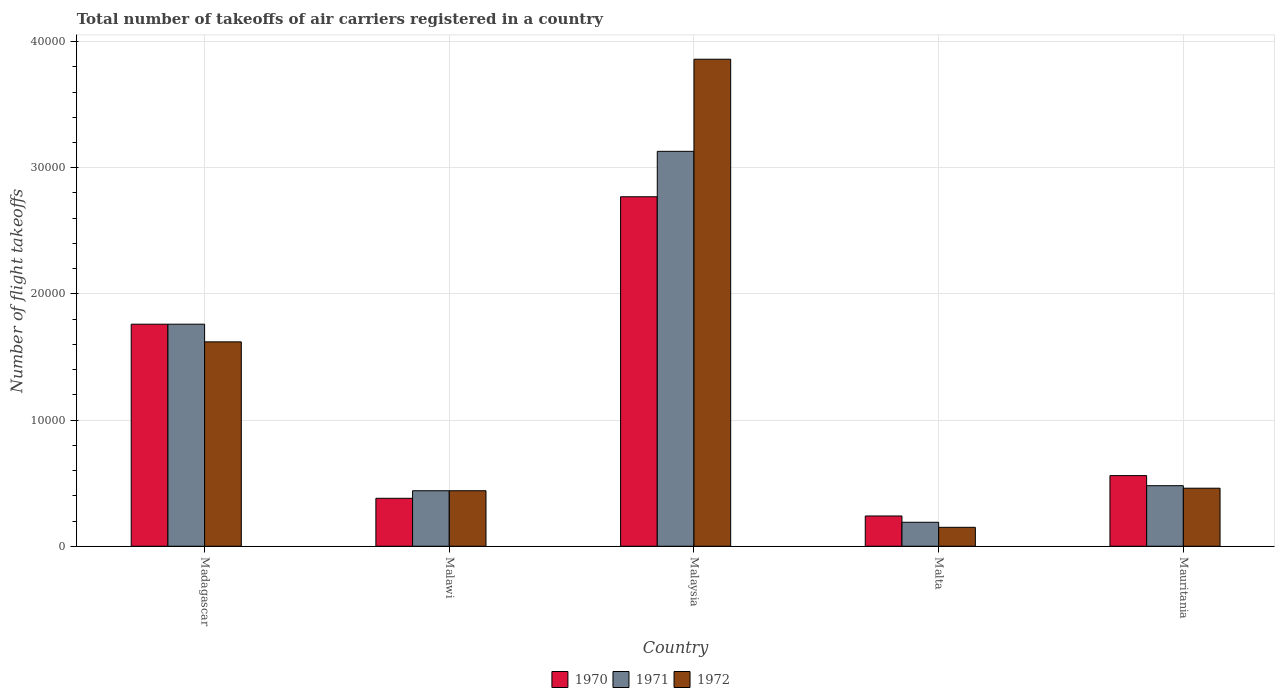Are the number of bars on each tick of the X-axis equal?
Keep it short and to the point. Yes. How many bars are there on the 1st tick from the left?
Make the answer very short. 3. What is the label of the 3rd group of bars from the left?
Offer a terse response. Malaysia. In how many cases, is the number of bars for a given country not equal to the number of legend labels?
Provide a short and direct response. 0. What is the total number of flight takeoffs in 1972 in Mauritania?
Make the answer very short. 4600. Across all countries, what is the maximum total number of flight takeoffs in 1972?
Give a very brief answer. 3.86e+04. Across all countries, what is the minimum total number of flight takeoffs in 1972?
Your answer should be very brief. 1500. In which country was the total number of flight takeoffs in 1972 maximum?
Your response must be concise. Malaysia. In which country was the total number of flight takeoffs in 1972 minimum?
Ensure brevity in your answer.  Malta. What is the total total number of flight takeoffs in 1972 in the graph?
Offer a terse response. 6.53e+04. What is the difference between the total number of flight takeoffs in 1972 in Madagascar and that in Malta?
Your answer should be compact. 1.47e+04. What is the difference between the total number of flight takeoffs in 1971 in Mauritania and the total number of flight takeoffs in 1972 in Madagascar?
Your response must be concise. -1.14e+04. What is the average total number of flight takeoffs in 1972 per country?
Provide a succinct answer. 1.31e+04. What is the difference between the total number of flight takeoffs of/in 1970 and total number of flight takeoffs of/in 1971 in Malawi?
Make the answer very short. -600. What is the ratio of the total number of flight takeoffs in 1970 in Madagascar to that in Mauritania?
Give a very brief answer. 3.14. What is the difference between the highest and the second highest total number of flight takeoffs in 1970?
Ensure brevity in your answer.  -1.01e+04. What is the difference between the highest and the lowest total number of flight takeoffs in 1970?
Your answer should be compact. 2.53e+04. How many countries are there in the graph?
Ensure brevity in your answer.  5. What is the difference between two consecutive major ticks on the Y-axis?
Your answer should be very brief. 10000. Are the values on the major ticks of Y-axis written in scientific E-notation?
Ensure brevity in your answer.  No. Does the graph contain grids?
Make the answer very short. Yes. Where does the legend appear in the graph?
Offer a very short reply. Bottom center. How many legend labels are there?
Provide a succinct answer. 3. What is the title of the graph?
Offer a very short reply. Total number of takeoffs of air carriers registered in a country. What is the label or title of the Y-axis?
Your answer should be very brief. Number of flight takeoffs. What is the Number of flight takeoffs of 1970 in Madagascar?
Your answer should be compact. 1.76e+04. What is the Number of flight takeoffs of 1971 in Madagascar?
Your answer should be very brief. 1.76e+04. What is the Number of flight takeoffs in 1972 in Madagascar?
Keep it short and to the point. 1.62e+04. What is the Number of flight takeoffs in 1970 in Malawi?
Offer a terse response. 3800. What is the Number of flight takeoffs in 1971 in Malawi?
Offer a very short reply. 4400. What is the Number of flight takeoffs of 1972 in Malawi?
Provide a succinct answer. 4400. What is the Number of flight takeoffs of 1970 in Malaysia?
Your response must be concise. 2.77e+04. What is the Number of flight takeoffs in 1971 in Malaysia?
Your answer should be very brief. 3.13e+04. What is the Number of flight takeoffs of 1972 in Malaysia?
Provide a succinct answer. 3.86e+04. What is the Number of flight takeoffs in 1970 in Malta?
Ensure brevity in your answer.  2400. What is the Number of flight takeoffs of 1971 in Malta?
Provide a short and direct response. 1900. What is the Number of flight takeoffs of 1972 in Malta?
Provide a short and direct response. 1500. What is the Number of flight takeoffs in 1970 in Mauritania?
Provide a succinct answer. 5600. What is the Number of flight takeoffs of 1971 in Mauritania?
Offer a very short reply. 4800. What is the Number of flight takeoffs in 1972 in Mauritania?
Your answer should be compact. 4600. Across all countries, what is the maximum Number of flight takeoffs of 1970?
Offer a terse response. 2.77e+04. Across all countries, what is the maximum Number of flight takeoffs of 1971?
Offer a very short reply. 3.13e+04. Across all countries, what is the maximum Number of flight takeoffs of 1972?
Ensure brevity in your answer.  3.86e+04. Across all countries, what is the minimum Number of flight takeoffs in 1970?
Offer a very short reply. 2400. Across all countries, what is the minimum Number of flight takeoffs in 1971?
Make the answer very short. 1900. Across all countries, what is the minimum Number of flight takeoffs in 1972?
Keep it short and to the point. 1500. What is the total Number of flight takeoffs in 1970 in the graph?
Make the answer very short. 5.71e+04. What is the total Number of flight takeoffs in 1971 in the graph?
Keep it short and to the point. 6.00e+04. What is the total Number of flight takeoffs in 1972 in the graph?
Make the answer very short. 6.53e+04. What is the difference between the Number of flight takeoffs of 1970 in Madagascar and that in Malawi?
Your response must be concise. 1.38e+04. What is the difference between the Number of flight takeoffs of 1971 in Madagascar and that in Malawi?
Make the answer very short. 1.32e+04. What is the difference between the Number of flight takeoffs in 1972 in Madagascar and that in Malawi?
Offer a very short reply. 1.18e+04. What is the difference between the Number of flight takeoffs in 1970 in Madagascar and that in Malaysia?
Your answer should be compact. -1.01e+04. What is the difference between the Number of flight takeoffs of 1971 in Madagascar and that in Malaysia?
Your answer should be very brief. -1.37e+04. What is the difference between the Number of flight takeoffs of 1972 in Madagascar and that in Malaysia?
Offer a terse response. -2.24e+04. What is the difference between the Number of flight takeoffs of 1970 in Madagascar and that in Malta?
Make the answer very short. 1.52e+04. What is the difference between the Number of flight takeoffs of 1971 in Madagascar and that in Malta?
Your response must be concise. 1.57e+04. What is the difference between the Number of flight takeoffs in 1972 in Madagascar and that in Malta?
Offer a very short reply. 1.47e+04. What is the difference between the Number of flight takeoffs in 1970 in Madagascar and that in Mauritania?
Give a very brief answer. 1.20e+04. What is the difference between the Number of flight takeoffs of 1971 in Madagascar and that in Mauritania?
Your response must be concise. 1.28e+04. What is the difference between the Number of flight takeoffs of 1972 in Madagascar and that in Mauritania?
Your answer should be compact. 1.16e+04. What is the difference between the Number of flight takeoffs of 1970 in Malawi and that in Malaysia?
Make the answer very short. -2.39e+04. What is the difference between the Number of flight takeoffs of 1971 in Malawi and that in Malaysia?
Offer a very short reply. -2.69e+04. What is the difference between the Number of flight takeoffs of 1972 in Malawi and that in Malaysia?
Your answer should be compact. -3.42e+04. What is the difference between the Number of flight takeoffs in 1970 in Malawi and that in Malta?
Keep it short and to the point. 1400. What is the difference between the Number of flight takeoffs in 1971 in Malawi and that in Malta?
Offer a very short reply. 2500. What is the difference between the Number of flight takeoffs of 1972 in Malawi and that in Malta?
Give a very brief answer. 2900. What is the difference between the Number of flight takeoffs in 1970 in Malawi and that in Mauritania?
Your answer should be very brief. -1800. What is the difference between the Number of flight takeoffs of 1971 in Malawi and that in Mauritania?
Provide a succinct answer. -400. What is the difference between the Number of flight takeoffs in 1972 in Malawi and that in Mauritania?
Provide a succinct answer. -200. What is the difference between the Number of flight takeoffs in 1970 in Malaysia and that in Malta?
Provide a short and direct response. 2.53e+04. What is the difference between the Number of flight takeoffs in 1971 in Malaysia and that in Malta?
Your answer should be very brief. 2.94e+04. What is the difference between the Number of flight takeoffs in 1972 in Malaysia and that in Malta?
Offer a terse response. 3.71e+04. What is the difference between the Number of flight takeoffs of 1970 in Malaysia and that in Mauritania?
Keep it short and to the point. 2.21e+04. What is the difference between the Number of flight takeoffs in 1971 in Malaysia and that in Mauritania?
Offer a very short reply. 2.65e+04. What is the difference between the Number of flight takeoffs in 1972 in Malaysia and that in Mauritania?
Your answer should be very brief. 3.40e+04. What is the difference between the Number of flight takeoffs of 1970 in Malta and that in Mauritania?
Keep it short and to the point. -3200. What is the difference between the Number of flight takeoffs of 1971 in Malta and that in Mauritania?
Offer a terse response. -2900. What is the difference between the Number of flight takeoffs in 1972 in Malta and that in Mauritania?
Keep it short and to the point. -3100. What is the difference between the Number of flight takeoffs of 1970 in Madagascar and the Number of flight takeoffs of 1971 in Malawi?
Make the answer very short. 1.32e+04. What is the difference between the Number of flight takeoffs in 1970 in Madagascar and the Number of flight takeoffs in 1972 in Malawi?
Your answer should be very brief. 1.32e+04. What is the difference between the Number of flight takeoffs of 1971 in Madagascar and the Number of flight takeoffs of 1972 in Malawi?
Offer a terse response. 1.32e+04. What is the difference between the Number of flight takeoffs in 1970 in Madagascar and the Number of flight takeoffs in 1971 in Malaysia?
Keep it short and to the point. -1.37e+04. What is the difference between the Number of flight takeoffs in 1970 in Madagascar and the Number of flight takeoffs in 1972 in Malaysia?
Offer a very short reply. -2.10e+04. What is the difference between the Number of flight takeoffs of 1971 in Madagascar and the Number of flight takeoffs of 1972 in Malaysia?
Offer a terse response. -2.10e+04. What is the difference between the Number of flight takeoffs in 1970 in Madagascar and the Number of flight takeoffs in 1971 in Malta?
Provide a succinct answer. 1.57e+04. What is the difference between the Number of flight takeoffs of 1970 in Madagascar and the Number of flight takeoffs of 1972 in Malta?
Ensure brevity in your answer.  1.61e+04. What is the difference between the Number of flight takeoffs in 1971 in Madagascar and the Number of flight takeoffs in 1972 in Malta?
Provide a succinct answer. 1.61e+04. What is the difference between the Number of flight takeoffs of 1970 in Madagascar and the Number of flight takeoffs of 1971 in Mauritania?
Offer a very short reply. 1.28e+04. What is the difference between the Number of flight takeoffs of 1970 in Madagascar and the Number of flight takeoffs of 1972 in Mauritania?
Provide a succinct answer. 1.30e+04. What is the difference between the Number of flight takeoffs of 1971 in Madagascar and the Number of flight takeoffs of 1972 in Mauritania?
Your answer should be compact. 1.30e+04. What is the difference between the Number of flight takeoffs in 1970 in Malawi and the Number of flight takeoffs in 1971 in Malaysia?
Give a very brief answer. -2.75e+04. What is the difference between the Number of flight takeoffs in 1970 in Malawi and the Number of flight takeoffs in 1972 in Malaysia?
Provide a short and direct response. -3.48e+04. What is the difference between the Number of flight takeoffs in 1971 in Malawi and the Number of flight takeoffs in 1972 in Malaysia?
Provide a succinct answer. -3.42e+04. What is the difference between the Number of flight takeoffs in 1970 in Malawi and the Number of flight takeoffs in 1971 in Malta?
Your response must be concise. 1900. What is the difference between the Number of flight takeoffs of 1970 in Malawi and the Number of flight takeoffs of 1972 in Malta?
Give a very brief answer. 2300. What is the difference between the Number of flight takeoffs of 1971 in Malawi and the Number of flight takeoffs of 1972 in Malta?
Make the answer very short. 2900. What is the difference between the Number of flight takeoffs of 1970 in Malawi and the Number of flight takeoffs of 1971 in Mauritania?
Your answer should be compact. -1000. What is the difference between the Number of flight takeoffs of 1970 in Malawi and the Number of flight takeoffs of 1972 in Mauritania?
Offer a terse response. -800. What is the difference between the Number of flight takeoffs of 1971 in Malawi and the Number of flight takeoffs of 1972 in Mauritania?
Your answer should be very brief. -200. What is the difference between the Number of flight takeoffs in 1970 in Malaysia and the Number of flight takeoffs in 1971 in Malta?
Offer a terse response. 2.58e+04. What is the difference between the Number of flight takeoffs of 1970 in Malaysia and the Number of flight takeoffs of 1972 in Malta?
Ensure brevity in your answer.  2.62e+04. What is the difference between the Number of flight takeoffs of 1971 in Malaysia and the Number of flight takeoffs of 1972 in Malta?
Your answer should be compact. 2.98e+04. What is the difference between the Number of flight takeoffs of 1970 in Malaysia and the Number of flight takeoffs of 1971 in Mauritania?
Your response must be concise. 2.29e+04. What is the difference between the Number of flight takeoffs of 1970 in Malaysia and the Number of flight takeoffs of 1972 in Mauritania?
Your answer should be compact. 2.31e+04. What is the difference between the Number of flight takeoffs in 1971 in Malaysia and the Number of flight takeoffs in 1972 in Mauritania?
Your answer should be compact. 2.67e+04. What is the difference between the Number of flight takeoffs of 1970 in Malta and the Number of flight takeoffs of 1971 in Mauritania?
Your answer should be very brief. -2400. What is the difference between the Number of flight takeoffs in 1970 in Malta and the Number of flight takeoffs in 1972 in Mauritania?
Keep it short and to the point. -2200. What is the difference between the Number of flight takeoffs in 1971 in Malta and the Number of flight takeoffs in 1972 in Mauritania?
Your answer should be very brief. -2700. What is the average Number of flight takeoffs of 1970 per country?
Provide a short and direct response. 1.14e+04. What is the average Number of flight takeoffs of 1971 per country?
Offer a terse response. 1.20e+04. What is the average Number of flight takeoffs of 1972 per country?
Keep it short and to the point. 1.31e+04. What is the difference between the Number of flight takeoffs in 1970 and Number of flight takeoffs in 1971 in Madagascar?
Provide a succinct answer. 0. What is the difference between the Number of flight takeoffs of 1970 and Number of flight takeoffs of 1972 in Madagascar?
Offer a very short reply. 1400. What is the difference between the Number of flight takeoffs of 1971 and Number of flight takeoffs of 1972 in Madagascar?
Your response must be concise. 1400. What is the difference between the Number of flight takeoffs in 1970 and Number of flight takeoffs in 1971 in Malawi?
Give a very brief answer. -600. What is the difference between the Number of flight takeoffs in 1970 and Number of flight takeoffs in 1972 in Malawi?
Keep it short and to the point. -600. What is the difference between the Number of flight takeoffs in 1970 and Number of flight takeoffs in 1971 in Malaysia?
Offer a terse response. -3600. What is the difference between the Number of flight takeoffs of 1970 and Number of flight takeoffs of 1972 in Malaysia?
Give a very brief answer. -1.09e+04. What is the difference between the Number of flight takeoffs in 1971 and Number of flight takeoffs in 1972 in Malaysia?
Offer a very short reply. -7300. What is the difference between the Number of flight takeoffs in 1970 and Number of flight takeoffs in 1971 in Malta?
Ensure brevity in your answer.  500. What is the difference between the Number of flight takeoffs in 1970 and Number of flight takeoffs in 1972 in Malta?
Ensure brevity in your answer.  900. What is the difference between the Number of flight takeoffs of 1970 and Number of flight takeoffs of 1971 in Mauritania?
Provide a short and direct response. 800. What is the ratio of the Number of flight takeoffs in 1970 in Madagascar to that in Malawi?
Your answer should be very brief. 4.63. What is the ratio of the Number of flight takeoffs in 1972 in Madagascar to that in Malawi?
Your response must be concise. 3.68. What is the ratio of the Number of flight takeoffs in 1970 in Madagascar to that in Malaysia?
Offer a terse response. 0.64. What is the ratio of the Number of flight takeoffs of 1971 in Madagascar to that in Malaysia?
Keep it short and to the point. 0.56. What is the ratio of the Number of flight takeoffs in 1972 in Madagascar to that in Malaysia?
Offer a terse response. 0.42. What is the ratio of the Number of flight takeoffs of 1970 in Madagascar to that in Malta?
Make the answer very short. 7.33. What is the ratio of the Number of flight takeoffs in 1971 in Madagascar to that in Malta?
Your answer should be very brief. 9.26. What is the ratio of the Number of flight takeoffs in 1972 in Madagascar to that in Malta?
Your answer should be compact. 10.8. What is the ratio of the Number of flight takeoffs in 1970 in Madagascar to that in Mauritania?
Give a very brief answer. 3.14. What is the ratio of the Number of flight takeoffs in 1971 in Madagascar to that in Mauritania?
Provide a succinct answer. 3.67. What is the ratio of the Number of flight takeoffs of 1972 in Madagascar to that in Mauritania?
Offer a very short reply. 3.52. What is the ratio of the Number of flight takeoffs in 1970 in Malawi to that in Malaysia?
Keep it short and to the point. 0.14. What is the ratio of the Number of flight takeoffs in 1971 in Malawi to that in Malaysia?
Ensure brevity in your answer.  0.14. What is the ratio of the Number of flight takeoffs in 1972 in Malawi to that in Malaysia?
Your answer should be very brief. 0.11. What is the ratio of the Number of flight takeoffs of 1970 in Malawi to that in Malta?
Make the answer very short. 1.58. What is the ratio of the Number of flight takeoffs in 1971 in Malawi to that in Malta?
Offer a very short reply. 2.32. What is the ratio of the Number of flight takeoffs in 1972 in Malawi to that in Malta?
Offer a terse response. 2.93. What is the ratio of the Number of flight takeoffs of 1970 in Malawi to that in Mauritania?
Your answer should be compact. 0.68. What is the ratio of the Number of flight takeoffs in 1972 in Malawi to that in Mauritania?
Make the answer very short. 0.96. What is the ratio of the Number of flight takeoffs of 1970 in Malaysia to that in Malta?
Offer a very short reply. 11.54. What is the ratio of the Number of flight takeoffs of 1971 in Malaysia to that in Malta?
Provide a succinct answer. 16.47. What is the ratio of the Number of flight takeoffs of 1972 in Malaysia to that in Malta?
Offer a terse response. 25.73. What is the ratio of the Number of flight takeoffs of 1970 in Malaysia to that in Mauritania?
Your response must be concise. 4.95. What is the ratio of the Number of flight takeoffs in 1971 in Malaysia to that in Mauritania?
Give a very brief answer. 6.52. What is the ratio of the Number of flight takeoffs of 1972 in Malaysia to that in Mauritania?
Make the answer very short. 8.39. What is the ratio of the Number of flight takeoffs of 1970 in Malta to that in Mauritania?
Make the answer very short. 0.43. What is the ratio of the Number of flight takeoffs in 1971 in Malta to that in Mauritania?
Your response must be concise. 0.4. What is the ratio of the Number of flight takeoffs in 1972 in Malta to that in Mauritania?
Your answer should be very brief. 0.33. What is the difference between the highest and the second highest Number of flight takeoffs of 1970?
Offer a terse response. 1.01e+04. What is the difference between the highest and the second highest Number of flight takeoffs of 1971?
Your answer should be compact. 1.37e+04. What is the difference between the highest and the second highest Number of flight takeoffs of 1972?
Give a very brief answer. 2.24e+04. What is the difference between the highest and the lowest Number of flight takeoffs of 1970?
Give a very brief answer. 2.53e+04. What is the difference between the highest and the lowest Number of flight takeoffs in 1971?
Provide a short and direct response. 2.94e+04. What is the difference between the highest and the lowest Number of flight takeoffs of 1972?
Your answer should be very brief. 3.71e+04. 